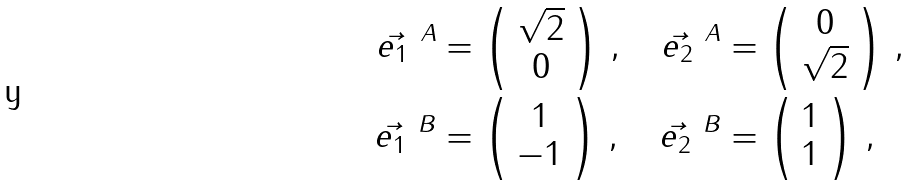Convert formula to latex. <formula><loc_0><loc_0><loc_500><loc_500>\vec { e _ { 1 } } ^ { \ A } & = \left ( \begin{array} { c } \sqrt { 2 } \\ 0 \end{array} \right ) \, , \quad \vec { e _ { 2 } } ^ { \ A } = \left ( \begin{array} { c } 0 \\ \sqrt { 2 } \end{array} \right ) \, , \\ \vec { e _ { 1 } } ^ { \ B } & = \left ( \begin{array} { c } 1 \\ - 1 \end{array} \right ) \, , \quad \vec { e _ { 2 } } ^ { \ B } = \left ( \begin{array} { c } 1 \\ 1 \end{array} \right ) \, ,</formula> 